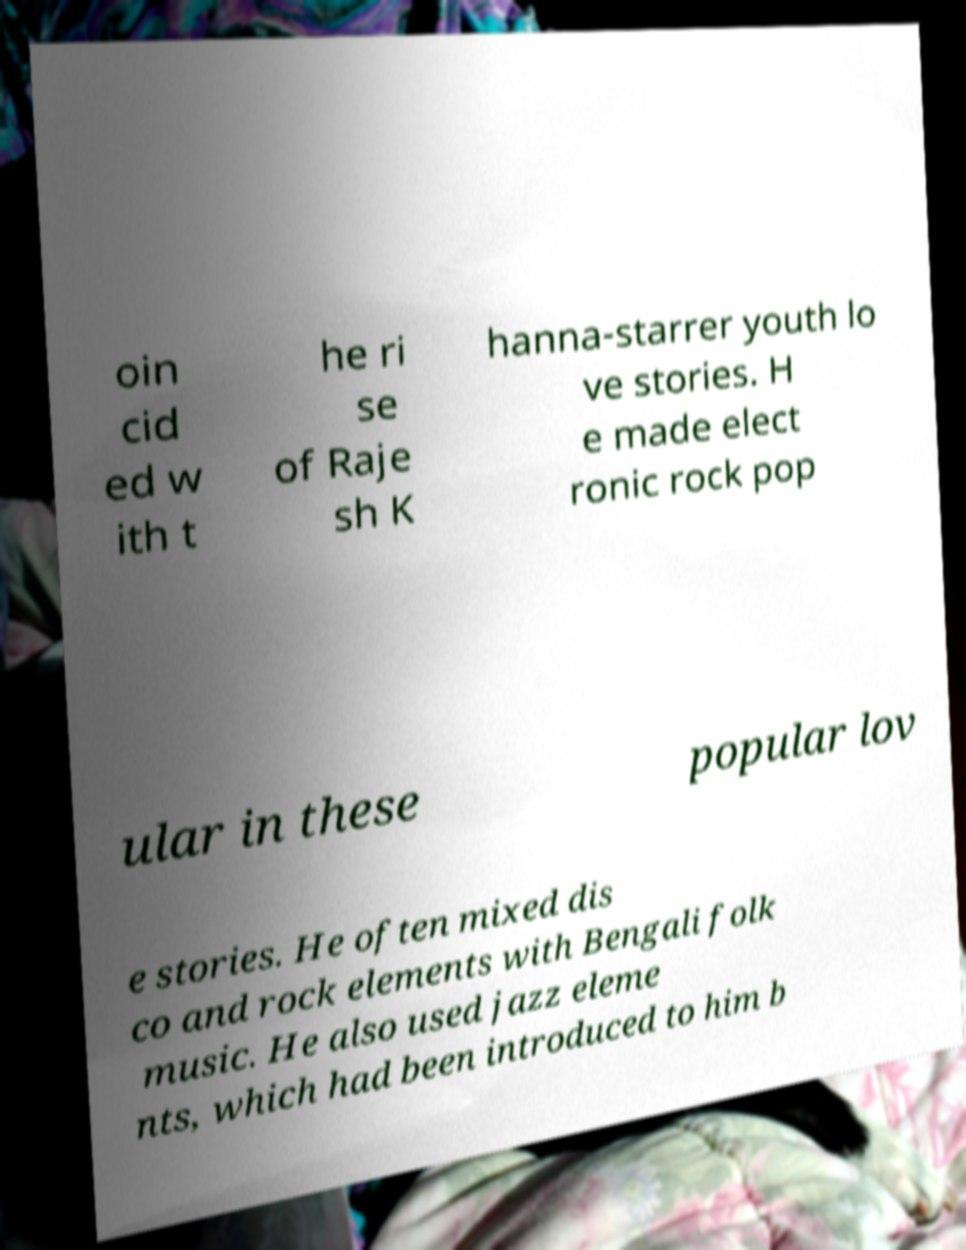Could you assist in decoding the text presented in this image and type it out clearly? oin cid ed w ith t he ri se of Raje sh K hanna-starrer youth lo ve stories. H e made elect ronic rock pop ular in these popular lov e stories. He often mixed dis co and rock elements with Bengali folk music. He also used jazz eleme nts, which had been introduced to him b 